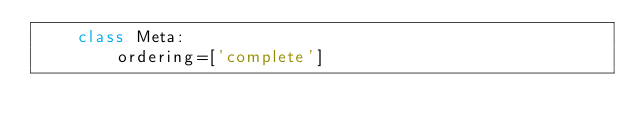Convert code to text. <code><loc_0><loc_0><loc_500><loc_500><_Python_>    class Meta:
        ordering=['complete']



        </code> 